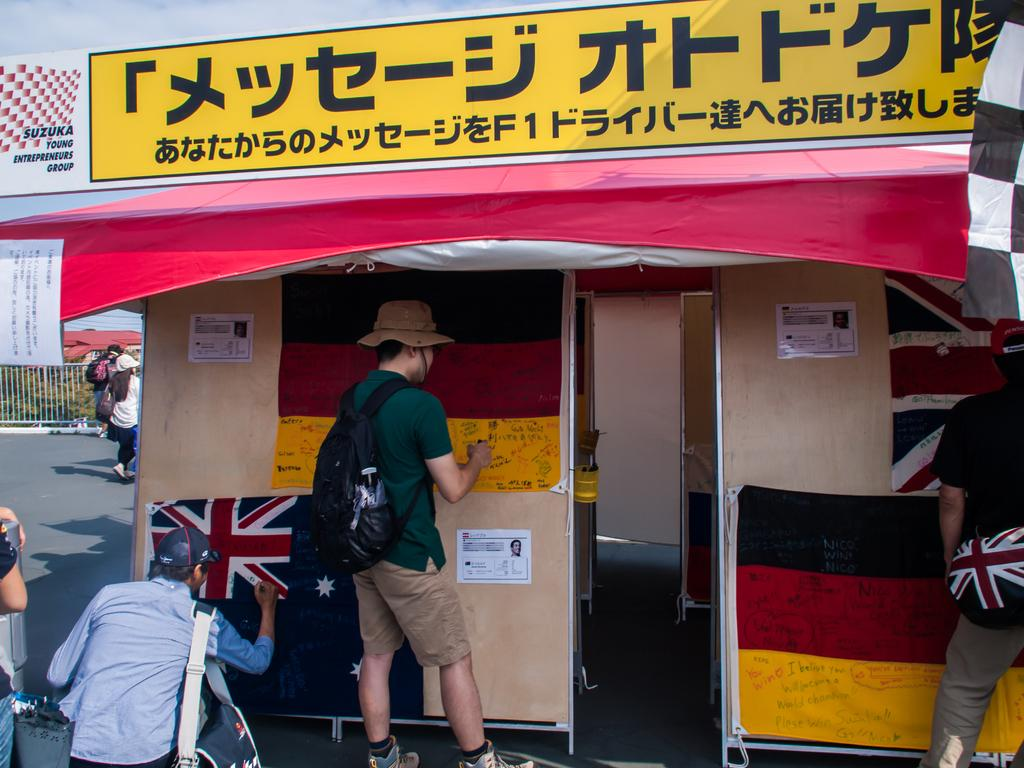<image>
Offer a succinct explanation of the picture presented. A small, portable building with Chinese letters on th etop, above a red awning has flags hanging from the wall that people are signing. 